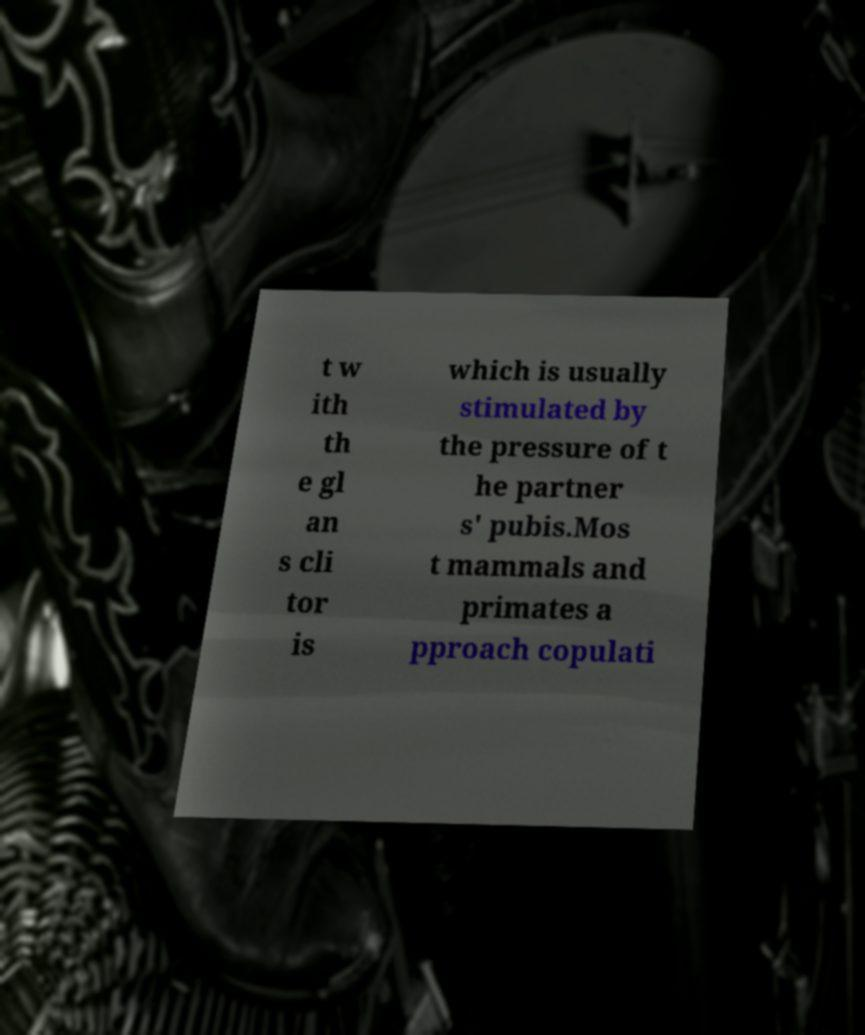I need the written content from this picture converted into text. Can you do that? t w ith th e gl an s cli tor is which is usually stimulated by the pressure of t he partner s' pubis.Mos t mammals and primates a pproach copulati 